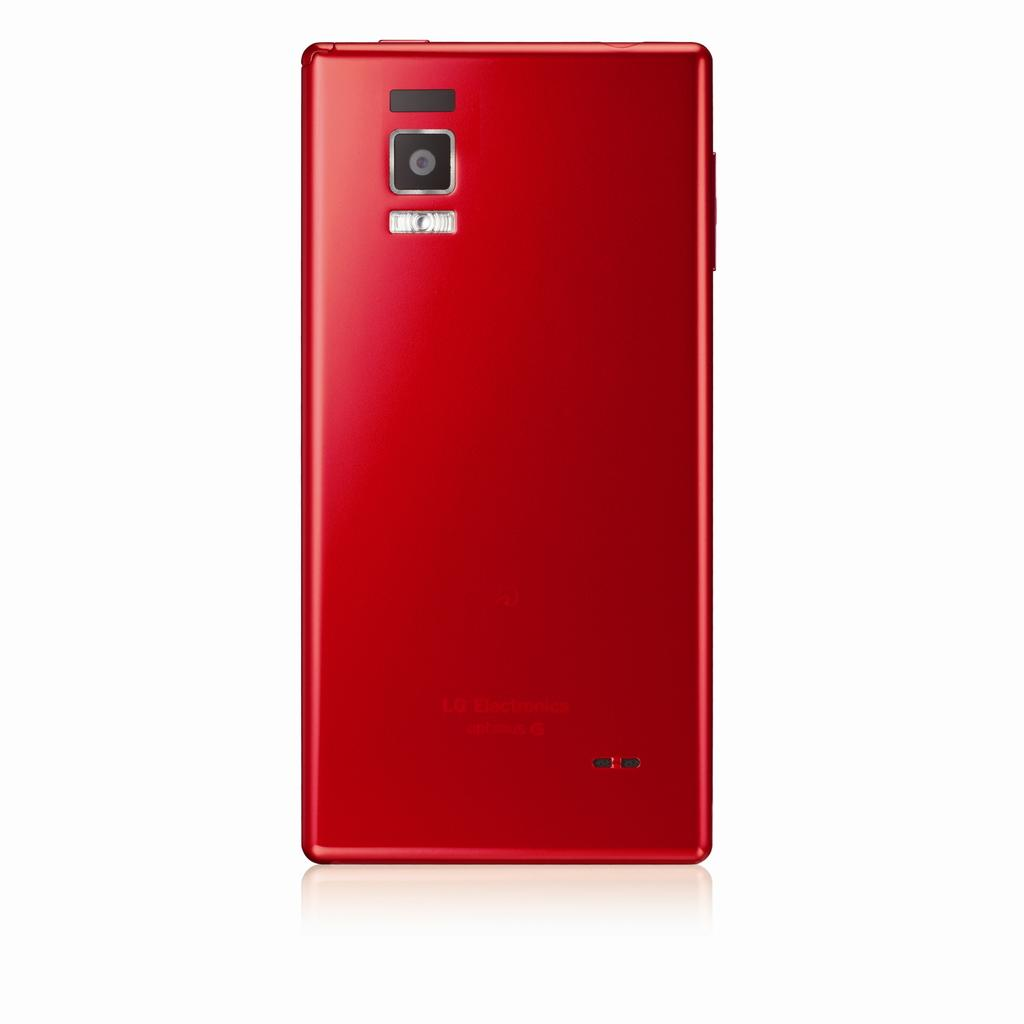<image>
Create a compact narrative representing the image presented. The back of an LG phone is shown in red. 